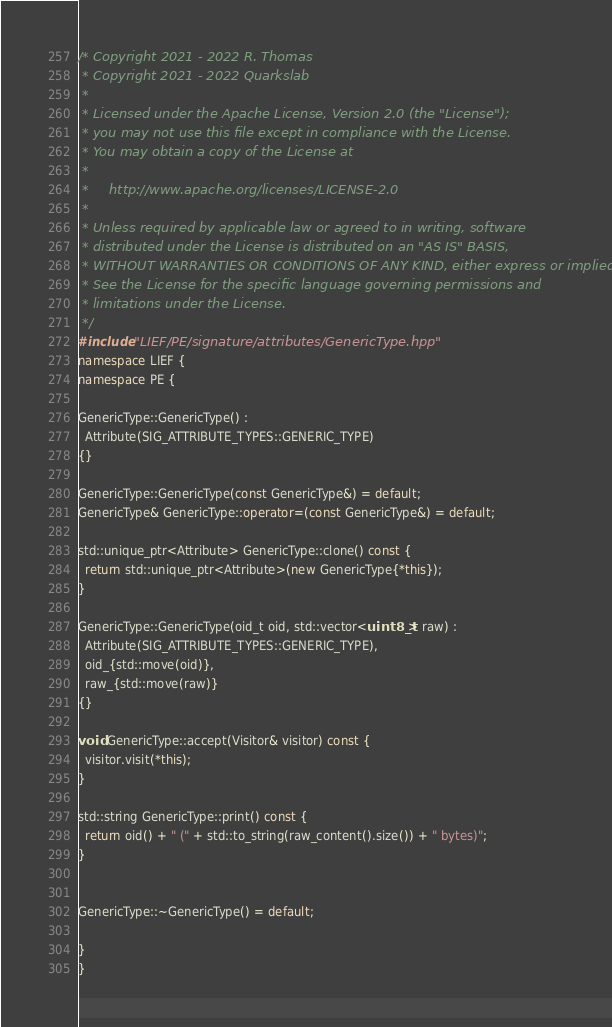Convert code to text. <code><loc_0><loc_0><loc_500><loc_500><_C++_>/* Copyright 2021 - 2022 R. Thomas
 * Copyright 2021 - 2022 Quarkslab
 *
 * Licensed under the Apache License, Version 2.0 (the "License");
 * you may not use this file except in compliance with the License.
 * You may obtain a copy of the License at
 *
 *     http://www.apache.org/licenses/LICENSE-2.0
 *
 * Unless required by applicable law or agreed to in writing, software
 * distributed under the License is distributed on an "AS IS" BASIS,
 * WITHOUT WARRANTIES OR CONDITIONS OF ANY KIND, either express or implied.
 * See the License for the specific language governing permissions and
 * limitations under the License.
 */
#include "LIEF/PE/signature/attributes/GenericType.hpp"
namespace LIEF {
namespace PE {

GenericType::GenericType() :
  Attribute(SIG_ATTRIBUTE_TYPES::GENERIC_TYPE)
{}

GenericType::GenericType(const GenericType&) = default;
GenericType& GenericType::operator=(const GenericType&) = default;

std::unique_ptr<Attribute> GenericType::clone() const {
  return std::unique_ptr<Attribute>(new GenericType{*this});
}

GenericType::GenericType(oid_t oid, std::vector<uint8_t> raw) :
  Attribute(SIG_ATTRIBUTE_TYPES::GENERIC_TYPE),
  oid_{std::move(oid)},
  raw_{std::move(raw)}
{}

void GenericType::accept(Visitor& visitor) const {
  visitor.visit(*this);
}

std::string GenericType::print() const {
  return oid() + " (" + std::to_string(raw_content().size()) + " bytes)";
}


GenericType::~GenericType() = default;

}
}
</code> 